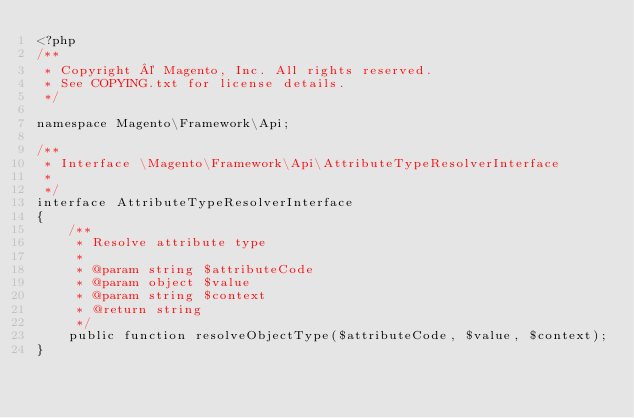<code> <loc_0><loc_0><loc_500><loc_500><_PHP_><?php
/**
 * Copyright © Magento, Inc. All rights reserved.
 * See COPYING.txt for license details.
 */

namespace Magento\Framework\Api;

/**
 * Interface \Magento\Framework\Api\AttributeTypeResolverInterface
 *
 */
interface AttributeTypeResolverInterface
{
    /**
     * Resolve attribute type
     *
     * @param string $attributeCode
     * @param object $value
     * @param string $context
     * @return string
     */
    public function resolveObjectType($attributeCode, $value, $context);
}
</code> 